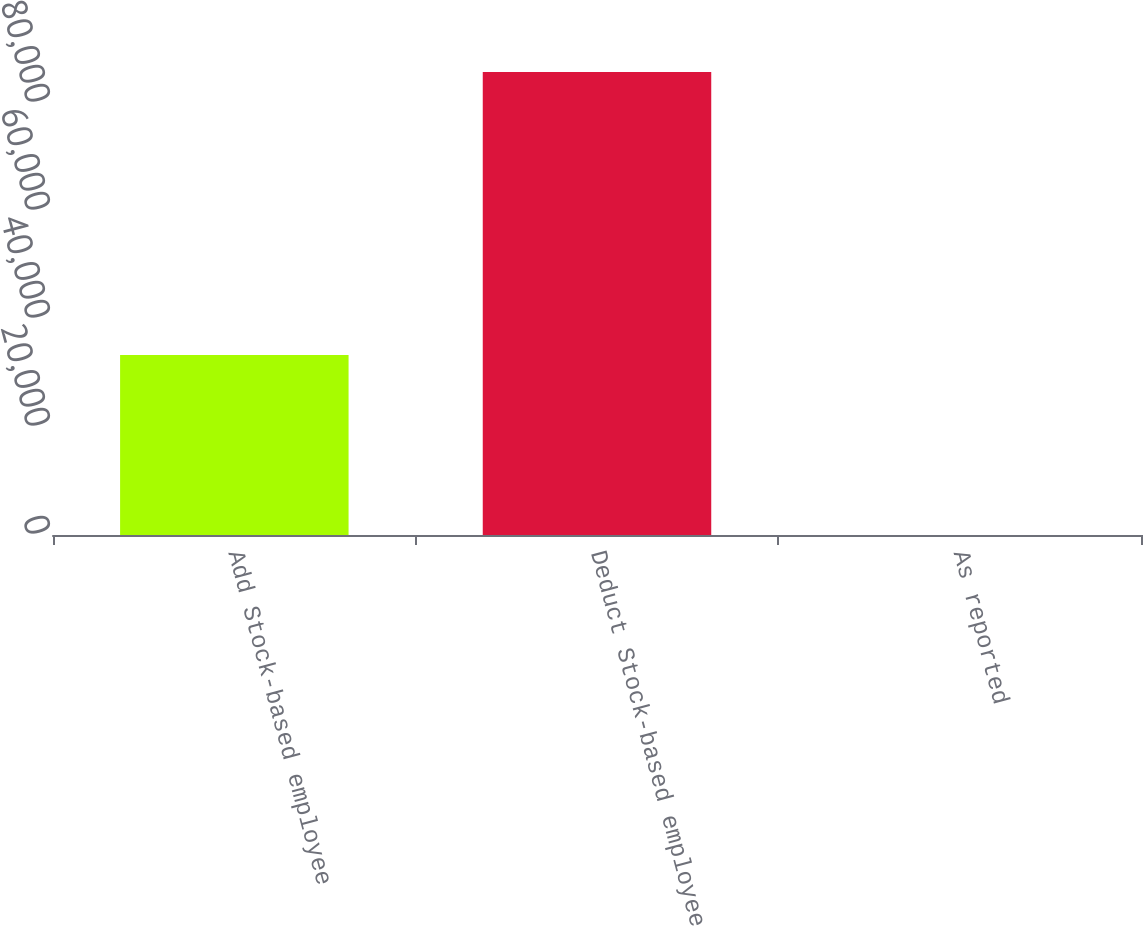Convert chart. <chart><loc_0><loc_0><loc_500><loc_500><bar_chart><fcel>Add Stock-based employee<fcel>Deduct Stock-based employee<fcel>As reported<nl><fcel>33321<fcel>85719<fcel>0.18<nl></chart> 